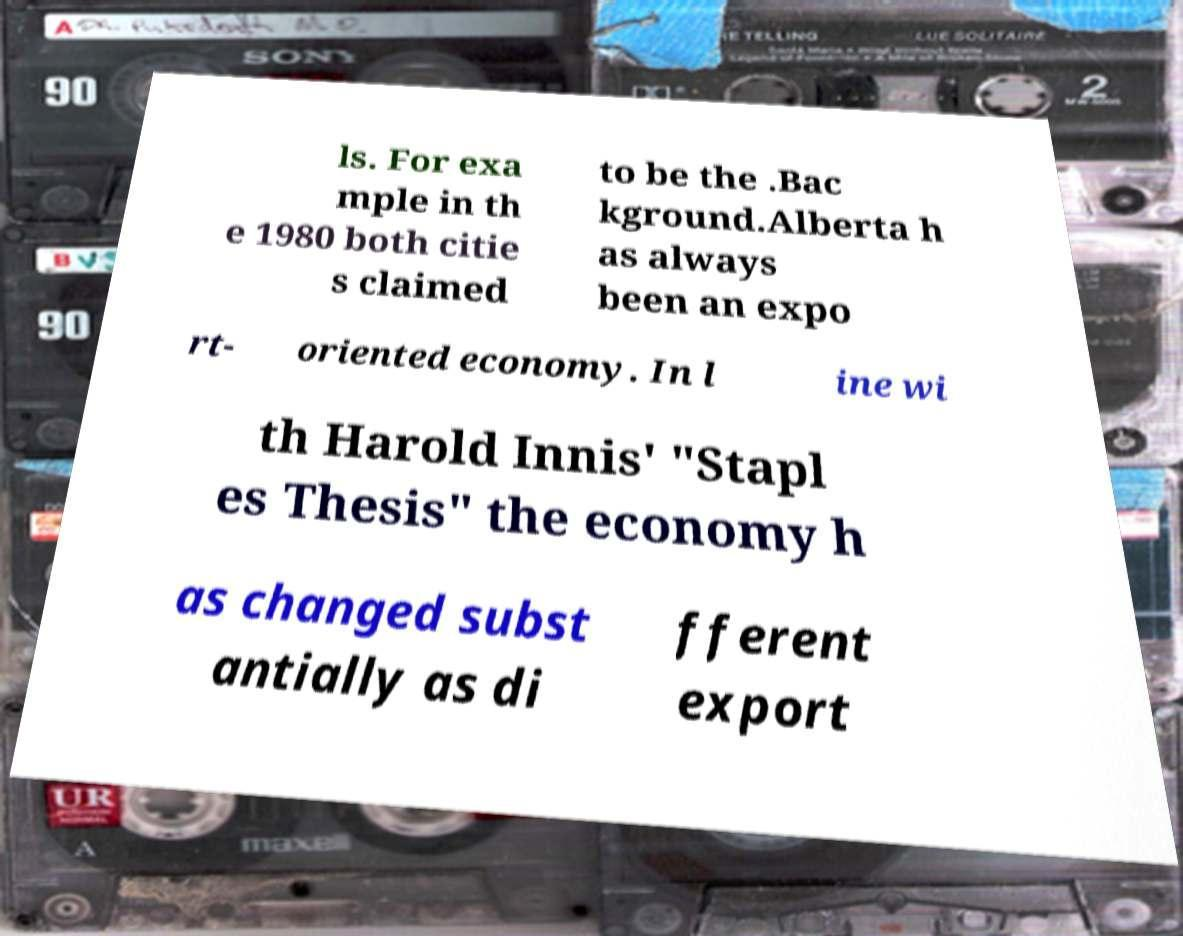What messages or text are displayed in this image? I need them in a readable, typed format. ls. For exa mple in th e 1980 both citie s claimed to be the .Bac kground.Alberta h as always been an expo rt- oriented economy. In l ine wi th Harold Innis' "Stapl es Thesis" the economy h as changed subst antially as di fferent export 